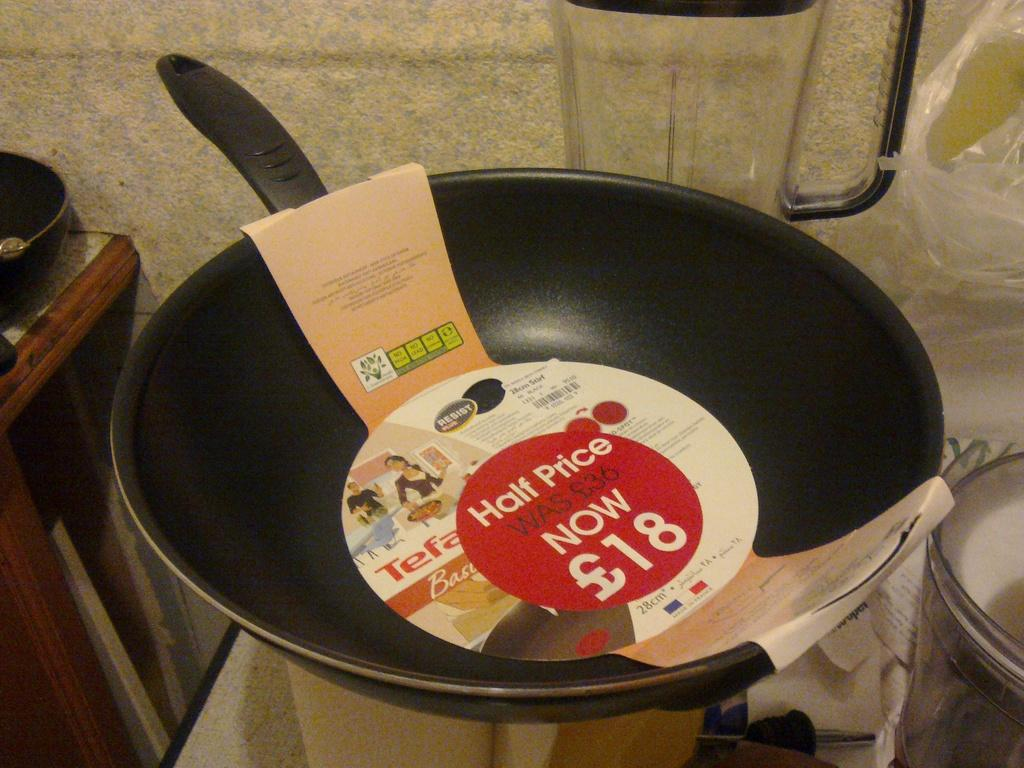<image>
Give a short and clear explanation of the subsequent image. A new skillet with the tage that reads half price still attached. 